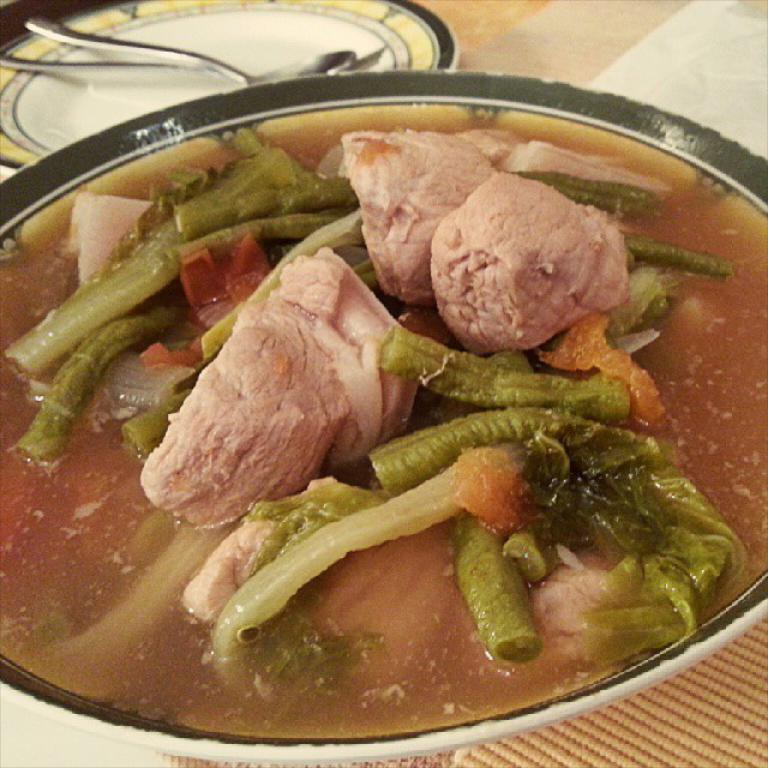What is in the bowl that is visible in the image? There is a bowl with food items in the image. What else can be seen in the image besides the bowl? There is a plate in the background of the image. What utensils are on the plate? The plate contains a spoon and fork. What type of paper is being used as a punishment in the image? There is no paper or punishment present in the image. 